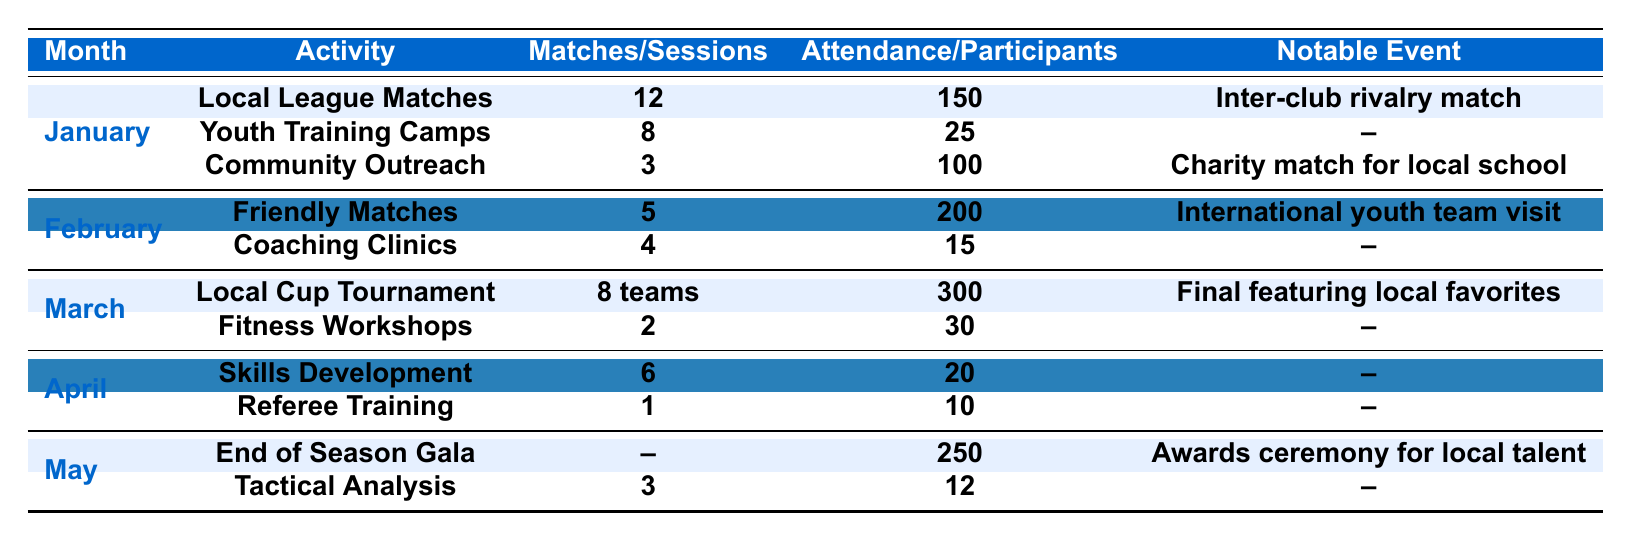What was the notable event for January? The notable event listed for January is the inter-club rivalry match during the local league matches.
Answer: Inter-club rivalry match How many local league matches were played in January? The table indicates that there were 12 local league matches conducted in January.
Answer: 12 What was the average attendance at the local cup tournament in March? According to the table, the average attendance for the local cup tournament in March was 300 people.
Answer: 300 How many participants were involved in the community outreach program in January? The table shows that there were 100 participants involved in the community outreach program in January.
Answer: 100 In which month did the end of season gala take place, and how many participants were there? The end of season gala occurred in May with a participation of 250 individuals.
Answer: May, 250 How many total matches were conducted across January and February? In January, there were 12 matches and in February, there were 5 friendly matches. Summing these gives 12 + 5 = 17 total matches conducted in these two months.
Answer: 17 What is the average number of sessions conducted for skills development and tactical analysis workshops in May? The skills development sessions in May were 6 and tactical analysis workshops were 3. The average is (6 + 3) / 2 = 4.5.
Answer: 4.5 Did the average attendance increase from friendly matches in February compared to local league matches in January? The average attendance for the friendly matches in February was 200, while for the local league matches in January it was 150. Since 200 is greater than 150, the attendance did increase.
Answer: Yes What was the total number of events conducted in January? January had 3 activities/events: local league matches, youth training camps, and community outreach programs. Therefore, the total number of events is 3.
Answer: 3 What is the total number of participants in all activities in May? In May, there were 250 participants in the end of season gala and 12 in the tactical analysis workshops. Adding these gives 250 + 12 = 262 total participants in May activities.
Answer: 262 